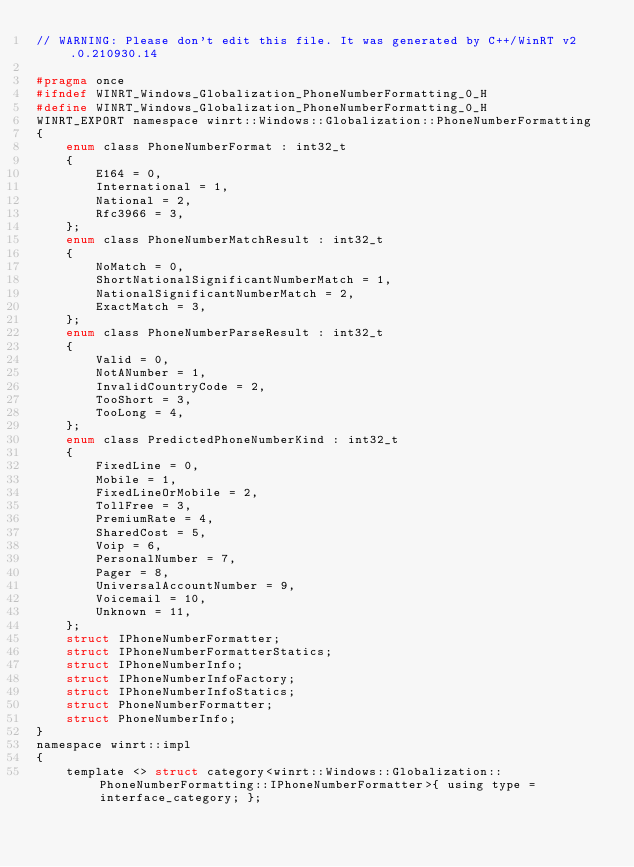Convert code to text. <code><loc_0><loc_0><loc_500><loc_500><_C_>// WARNING: Please don't edit this file. It was generated by C++/WinRT v2.0.210930.14

#pragma once
#ifndef WINRT_Windows_Globalization_PhoneNumberFormatting_0_H
#define WINRT_Windows_Globalization_PhoneNumberFormatting_0_H
WINRT_EXPORT namespace winrt::Windows::Globalization::PhoneNumberFormatting
{
    enum class PhoneNumberFormat : int32_t
    {
        E164 = 0,
        International = 1,
        National = 2,
        Rfc3966 = 3,
    };
    enum class PhoneNumberMatchResult : int32_t
    {
        NoMatch = 0,
        ShortNationalSignificantNumberMatch = 1,
        NationalSignificantNumberMatch = 2,
        ExactMatch = 3,
    };
    enum class PhoneNumberParseResult : int32_t
    {
        Valid = 0,
        NotANumber = 1,
        InvalidCountryCode = 2,
        TooShort = 3,
        TooLong = 4,
    };
    enum class PredictedPhoneNumberKind : int32_t
    {
        FixedLine = 0,
        Mobile = 1,
        FixedLineOrMobile = 2,
        TollFree = 3,
        PremiumRate = 4,
        SharedCost = 5,
        Voip = 6,
        PersonalNumber = 7,
        Pager = 8,
        UniversalAccountNumber = 9,
        Voicemail = 10,
        Unknown = 11,
    };
    struct IPhoneNumberFormatter;
    struct IPhoneNumberFormatterStatics;
    struct IPhoneNumberInfo;
    struct IPhoneNumberInfoFactory;
    struct IPhoneNumberInfoStatics;
    struct PhoneNumberFormatter;
    struct PhoneNumberInfo;
}
namespace winrt::impl
{
    template <> struct category<winrt::Windows::Globalization::PhoneNumberFormatting::IPhoneNumberFormatter>{ using type = interface_category; };</code> 